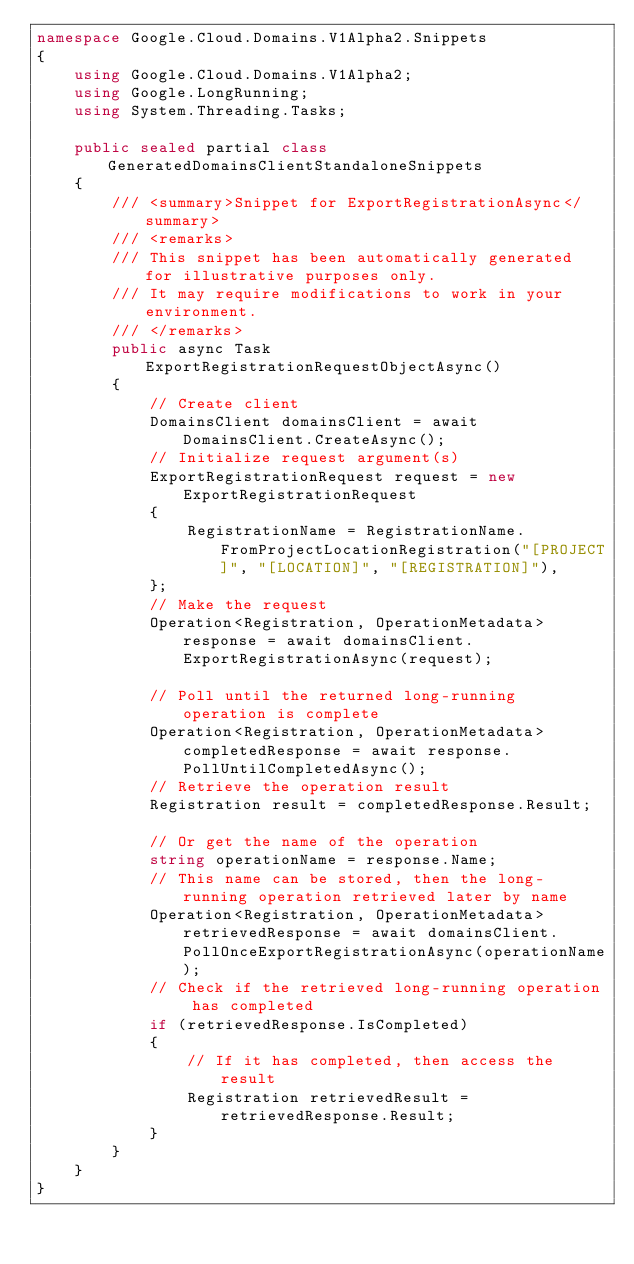<code> <loc_0><loc_0><loc_500><loc_500><_C#_>namespace Google.Cloud.Domains.V1Alpha2.Snippets
{
    using Google.Cloud.Domains.V1Alpha2;
    using Google.LongRunning;
    using System.Threading.Tasks;

    public sealed partial class GeneratedDomainsClientStandaloneSnippets
    {
        /// <summary>Snippet for ExportRegistrationAsync</summary>
        /// <remarks>
        /// This snippet has been automatically generated for illustrative purposes only.
        /// It may require modifications to work in your environment.
        /// </remarks>
        public async Task ExportRegistrationRequestObjectAsync()
        {
            // Create client
            DomainsClient domainsClient = await DomainsClient.CreateAsync();
            // Initialize request argument(s)
            ExportRegistrationRequest request = new ExportRegistrationRequest
            {
                RegistrationName = RegistrationName.FromProjectLocationRegistration("[PROJECT]", "[LOCATION]", "[REGISTRATION]"),
            };
            // Make the request
            Operation<Registration, OperationMetadata> response = await domainsClient.ExportRegistrationAsync(request);

            // Poll until the returned long-running operation is complete
            Operation<Registration, OperationMetadata> completedResponse = await response.PollUntilCompletedAsync();
            // Retrieve the operation result
            Registration result = completedResponse.Result;

            // Or get the name of the operation
            string operationName = response.Name;
            // This name can be stored, then the long-running operation retrieved later by name
            Operation<Registration, OperationMetadata> retrievedResponse = await domainsClient.PollOnceExportRegistrationAsync(operationName);
            // Check if the retrieved long-running operation has completed
            if (retrievedResponse.IsCompleted)
            {
                // If it has completed, then access the result
                Registration retrievedResult = retrievedResponse.Result;
            }
        }
    }
}
</code> 